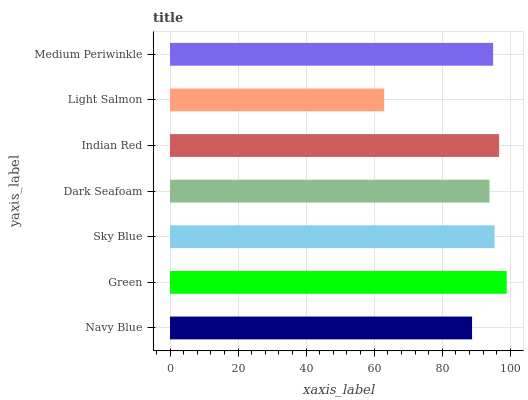Is Light Salmon the minimum?
Answer yes or no. Yes. Is Green the maximum?
Answer yes or no. Yes. Is Sky Blue the minimum?
Answer yes or no. No. Is Sky Blue the maximum?
Answer yes or no. No. Is Green greater than Sky Blue?
Answer yes or no. Yes. Is Sky Blue less than Green?
Answer yes or no. Yes. Is Sky Blue greater than Green?
Answer yes or no. No. Is Green less than Sky Blue?
Answer yes or no. No. Is Medium Periwinkle the high median?
Answer yes or no. Yes. Is Medium Periwinkle the low median?
Answer yes or no. Yes. Is Navy Blue the high median?
Answer yes or no. No. Is Light Salmon the low median?
Answer yes or no. No. 